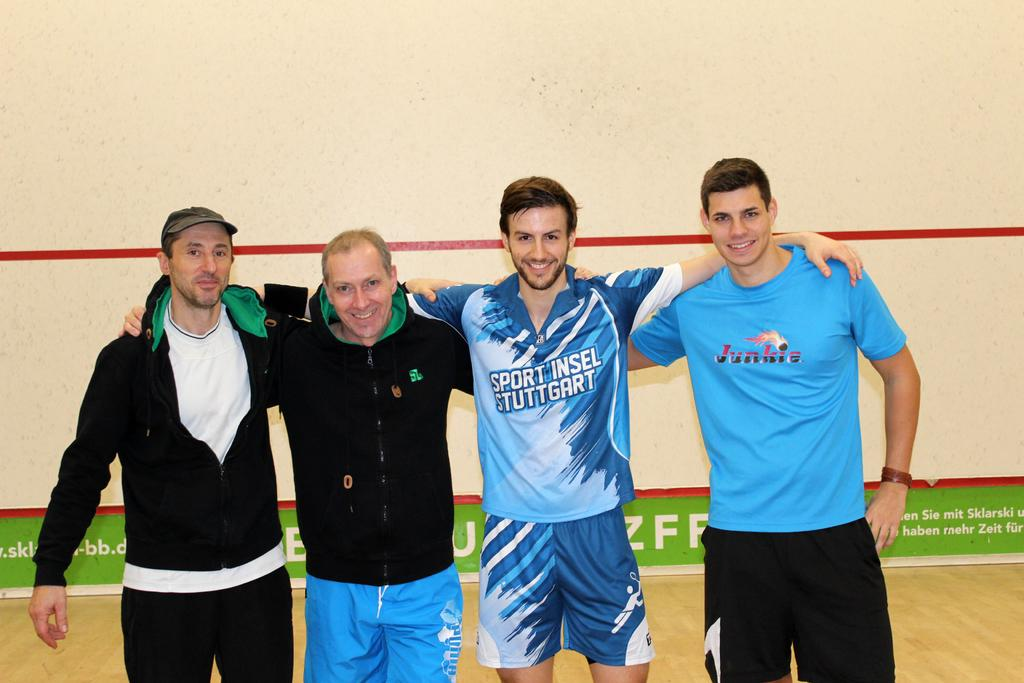<image>
Provide a brief description of the given image. A group of men holding shoulders, one that has a blue shirt that says Junkie on it. 